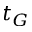<formula> <loc_0><loc_0><loc_500><loc_500>t _ { G }</formula> 